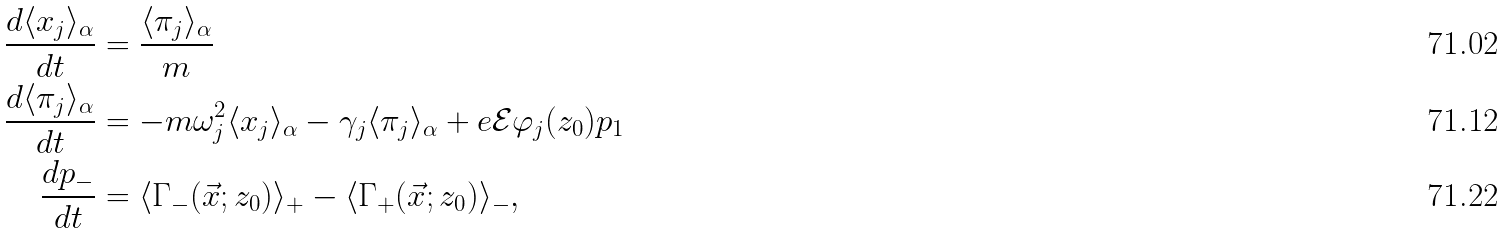Convert formula to latex. <formula><loc_0><loc_0><loc_500><loc_500>\frac { d \langle x _ { j } \rangle _ { \alpha } } { d t } & = \frac { \langle \pi _ { j } \rangle _ { \alpha } } { m } \\ \frac { d \langle \pi _ { j } \rangle _ { \alpha } } { d t } & = - m \omega _ { j } ^ { 2 } \langle x _ { j } \rangle _ { \alpha } - \gamma _ { j } \langle \pi _ { j } \rangle _ { \alpha } + e \mathcal { E } \varphi _ { j } ( z _ { 0 } ) p _ { 1 } \\ \frac { d p _ { - } } { d t } & = \langle \Gamma _ { - } ( \vec { x } ; z _ { 0 } ) \rangle _ { + } - \langle \Gamma _ { + } ( \vec { x } ; z _ { 0 } ) \rangle _ { - } ,</formula> 